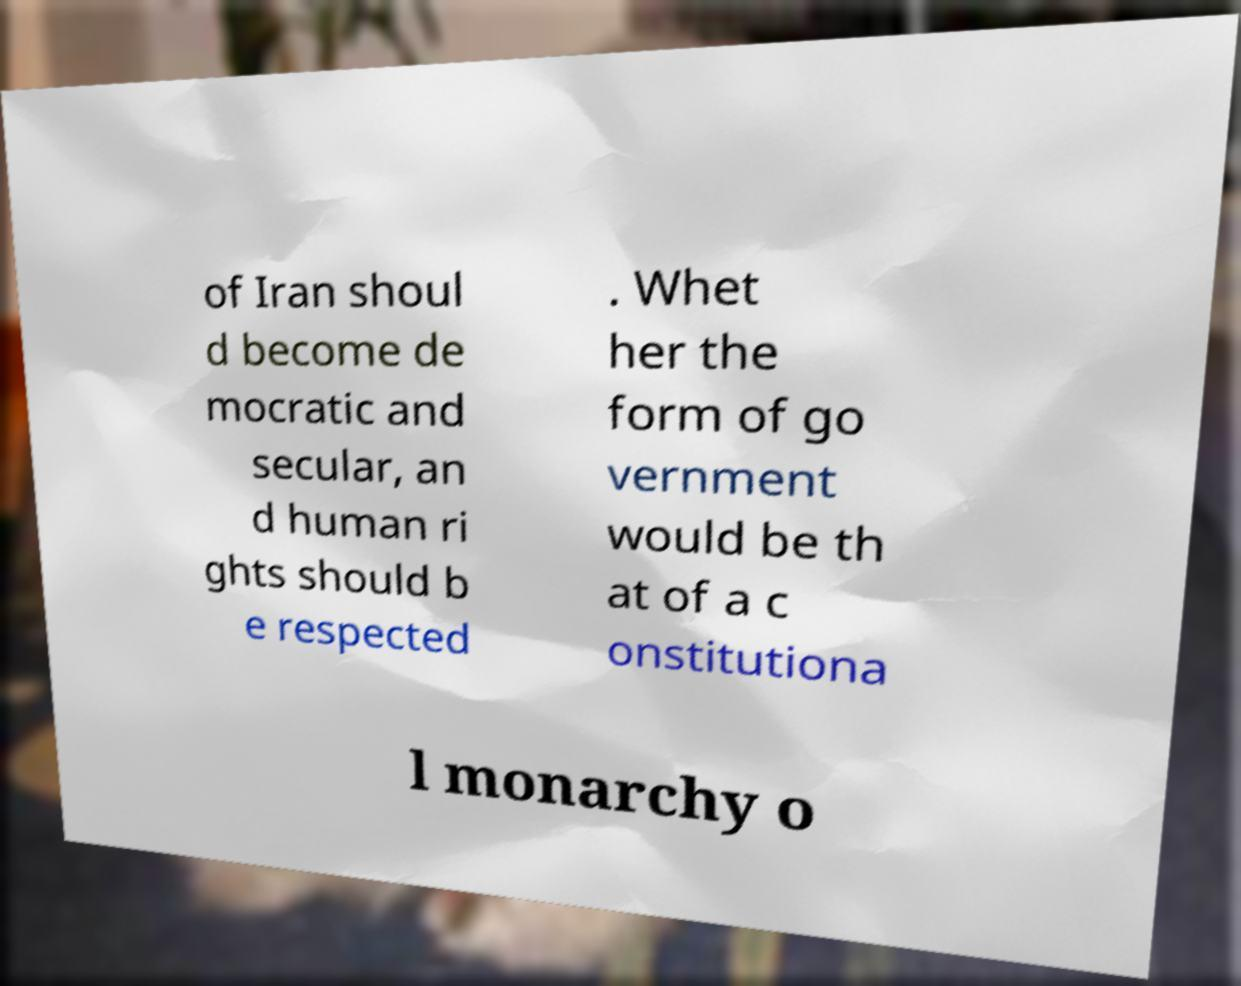For documentation purposes, I need the text within this image transcribed. Could you provide that? of Iran shoul d become de mocratic and secular, an d human ri ghts should b e respected . Whet her the form of go vernment would be th at of a c onstitutiona l monarchy o 